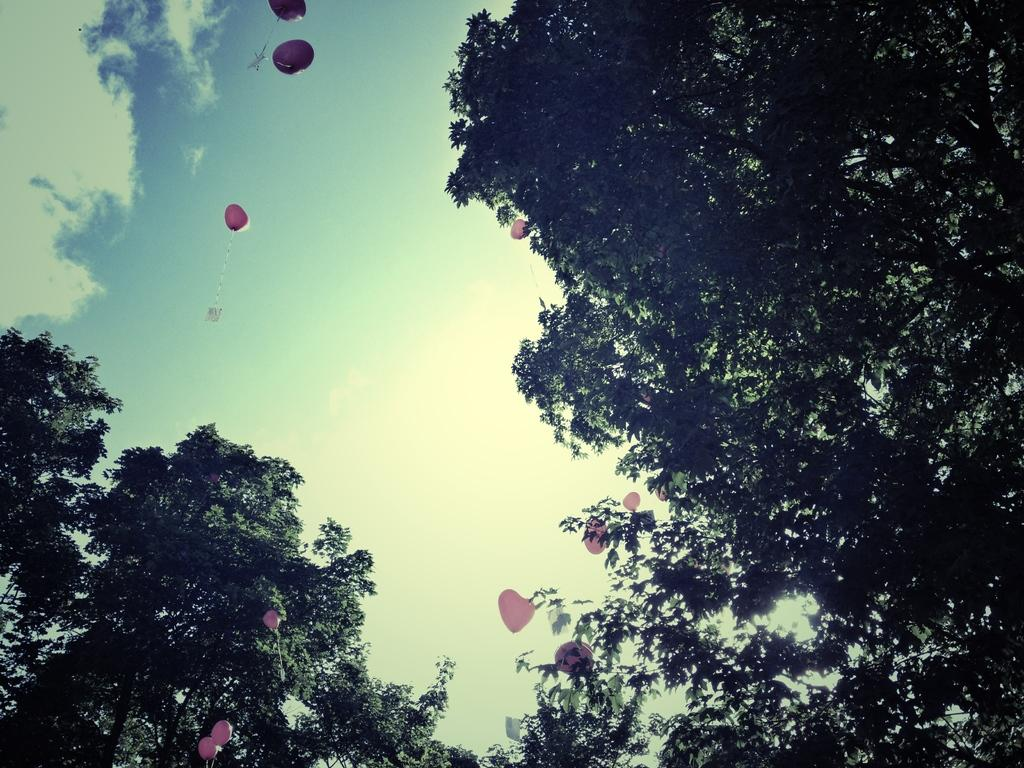What type of vegetation is present in the image? There are trees in the image. What type of decoration can be seen in the image? There are red color heart balloons in the image. What are the balloons doing in the image? The balloons are flying. What can be seen in the background of the image? The sky is visible in the image. What is the color of the sky in the image? The sky has a white and blue color. What type of government is depicted in the image? There is no depiction of a government in the image; it features trees and heart balloons. Can you see a bottle in the image? There is no bottle present in the image. 